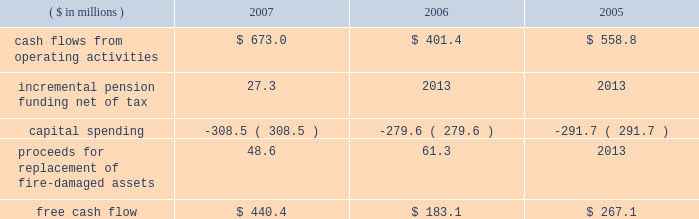Page 30 of 94 are included in capital spending amounts .
Another example is the company 2019s decision in 2007 to contribute an additional $ 44.5 million ( $ 27.3 million ) to its pension plans as part of its overall debt reduction plan .
Based on this , our consolidated free cash flow is summarized as follows: .
Based on information currently available , we estimate cash flows from operating activities for 2008 to be approximately $ 650 million , capital spending to be approximately $ 350 million and free cash flow to be in the $ 300 million range .
Capital spending of $ 259.9 million ( net of $ 48.6 million in insurance recoveries ) in 2007 was below depreciation and amortization expense of $ 281 million .
We continue to invest capital in our best performing operations , including projects to increase custom can capabilities , improve beverage can and end making productivity and add more beverage can capacity in europe , as well as expenditures in the aerospace and technologies segment .
Of the $ 350 million of planned capital spending for 2008 , approximately $ 180 million will be spent on top-line sales growth projects .
Debt facilities and refinancing interest-bearing debt at december 31 , 2007 , decreased $ 93.1 million to $ 2358.6 million from $ 2451.7 million at december 31 , 2006 .
The 2007 debt decrease from 2006 was primarily attributed to debt payments offset by higher foreign exchange rates .
At december 31 , 2007 , $ 705 million was available under the company 2019s multi-currency revolving credit facilities .
The company also had $ 345 million of short-term uncommitted credit facilities available at the end of the year , of which $ 49.7 million was outstanding .
On october 13 , 2005 , ball refinanced its senior secured credit facilities and during the third and fourth quarters of 2005 , ball redeemed its 7.75% ( 7.75 % ) senior notes due august 2006 primarily through the drawdown of funds under the new credit facilities .
The refinancing and redemption resulted in a pretax debt refinancing charge of $ 19.3 million ( $ 12.3 million after tax ) to reflect the call premium associated with the senior notes and the write off of unamortized debt issuance costs .
The company has a receivables sales agreement that provides for the ongoing , revolving sale of a designated pool of trade accounts receivable of ball 2019s north american packaging operations , up to $ 250 million .
The agreement qualifies as off-balance sheet financing under the provisions of statement of financial accounting standards ( sfas ) no .
140 , as amended by sfas no .
156 .
Net funds received from the sale of the accounts receivable totaled $ 170 million and $ 201.3 million at december 31 , 2007 and 2006 , respectively , and are reflected as a reduction of accounts receivable in the consolidated balance sheets .
The company was not in default of any loan agreement at december 31 , 2007 , and has met all payment obligations .
The u.s .
Note agreements , bank credit agreement and industrial development revenue bond agreements contain certain restrictions relating to dividends , investments , financial ratios , guarantees and the incurrence of additional indebtedness .
Additional details about the company 2019s receivables sales agreement and debt are available in notes 7 and 13 , respectively , accompanying the consolidated financial statements within item 8 of this report. .
What would 2007 free cash flow have been without capital spending , in millions? 
Computations: (308.5 + 440.4)
Answer: 748.9. 